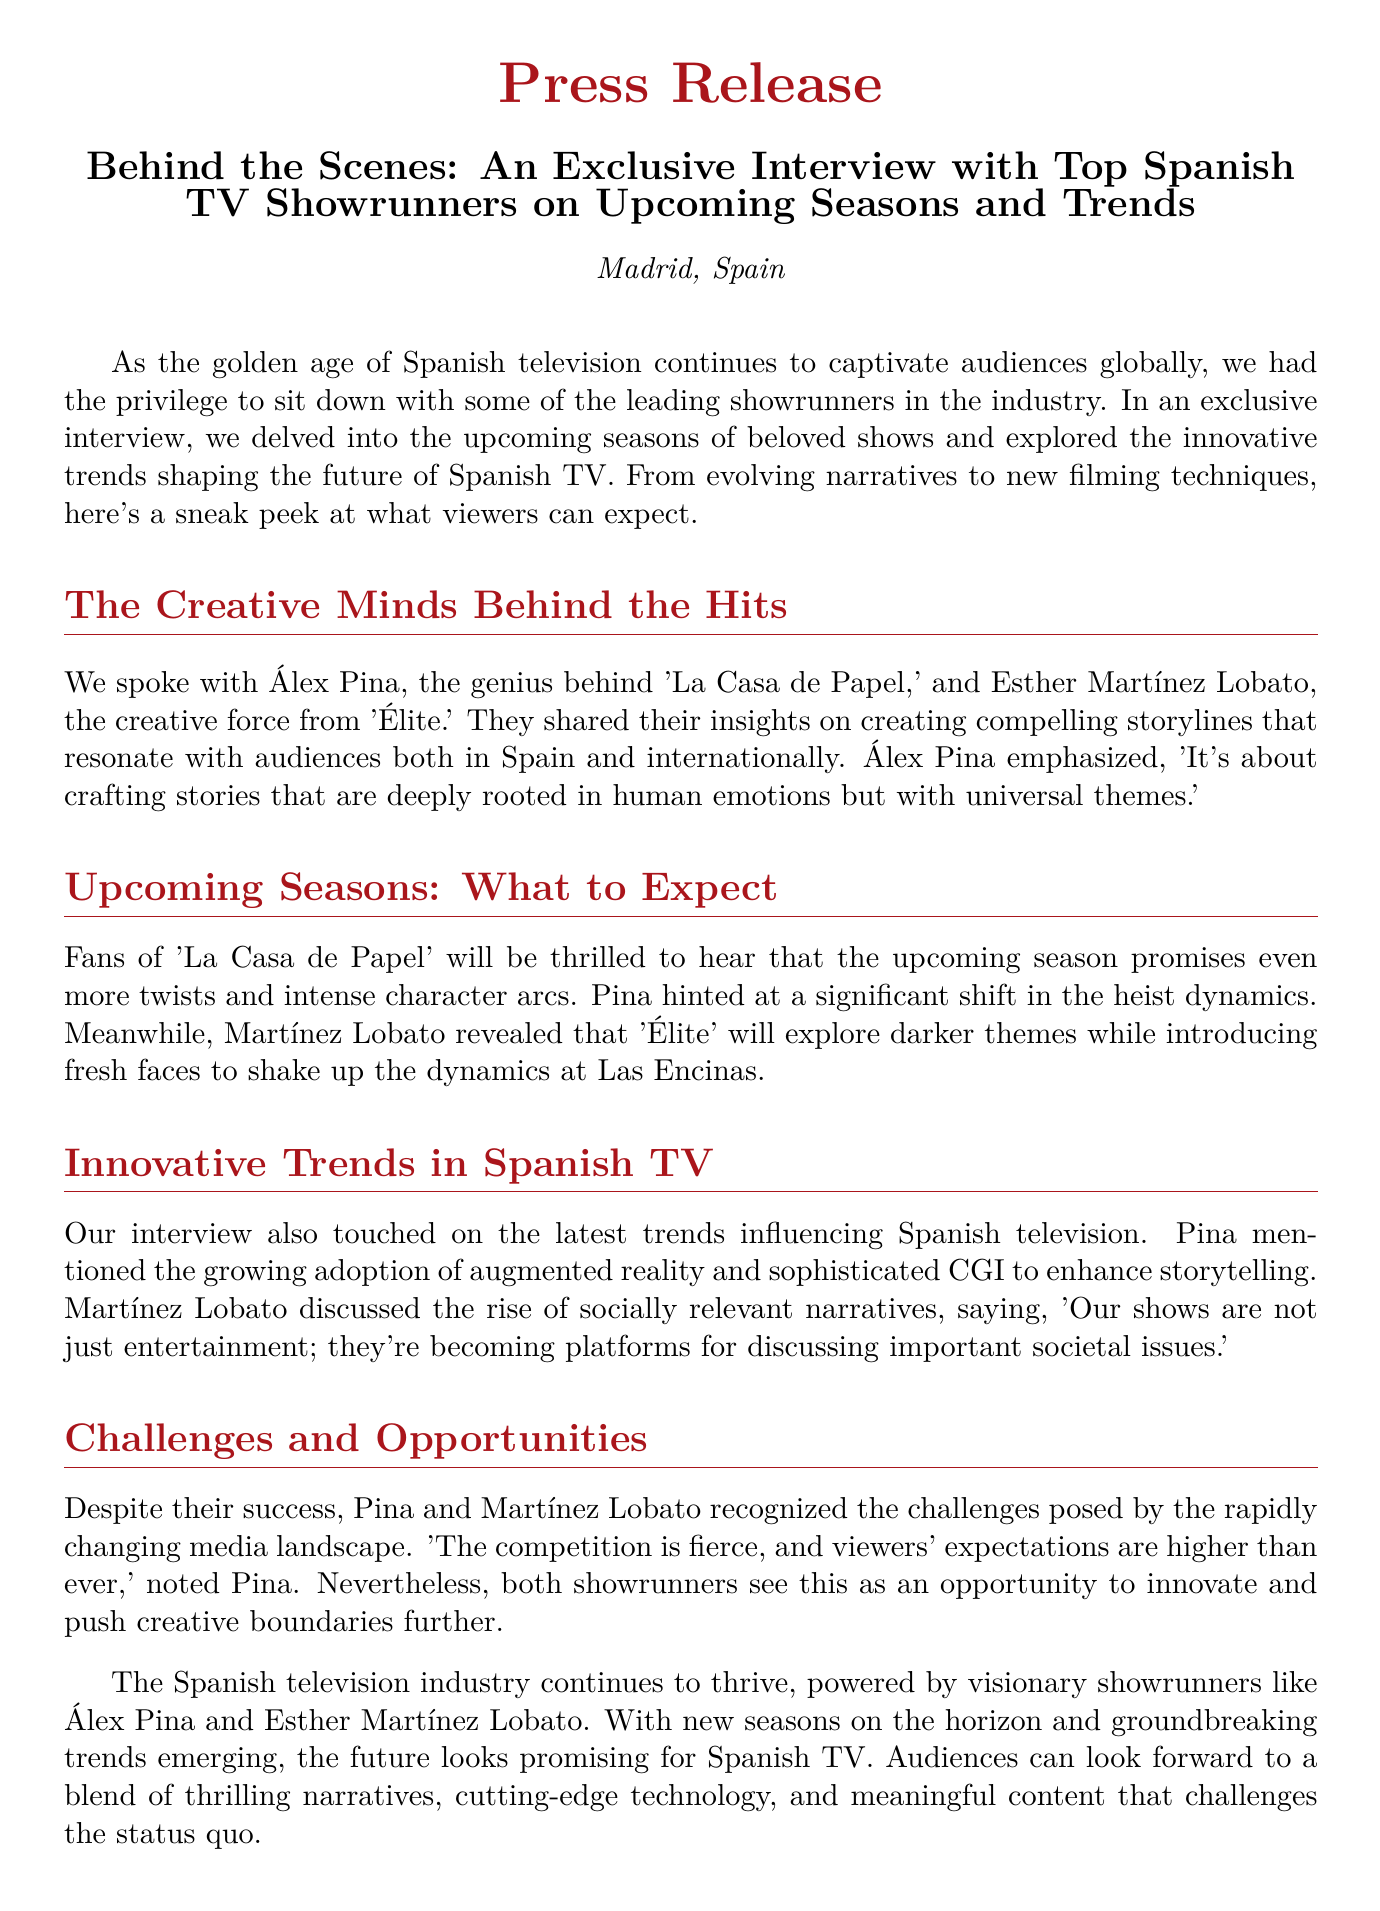What is the title of the press release? The title is prominently displayed in the document, detailing the exclusive interview and the subject matter of Spanish TV.
Answer: Behind the Scenes: An Exclusive Interview with Top Spanish TV Showrunners on Upcoming Seasons and Trends Who are the two showrunners interviewed? The document mentions both showrunners by name, sharing their insights into the Spanish television industry.
Answer: Álex Pina and Esther Martínez Lobato What show is Álex Pina known for? The document specifically references the show he created, which has gained international acclaim.
Answer: La Casa de Papel What theme will 'Élite' explore in the upcoming season? The document provides insight into the thematic direction of the series moving forward.
Answer: Darker themes What technology did Pina mention enhancing storytelling? The mention of technology used in storytelling highlights the innovation within the industry discussed in the interview.
Answer: Augmented reality What is mentioned as a significant challenge in the current media landscape? The document identifies a primary concern that both showrunners face in the competitive environment.
Answer: Fierce competition What societal aspect is becoming more prominent in Spanish TV shows? The document states a trend regarding the content focus in modern Spanish television.
Answer: Socially relevant narratives What does Martínez Lobato believe about the role of their shows? The document quotes her perspective on the broader purpose of the content they create.
Answer: Platforms for discussing important societal issues 